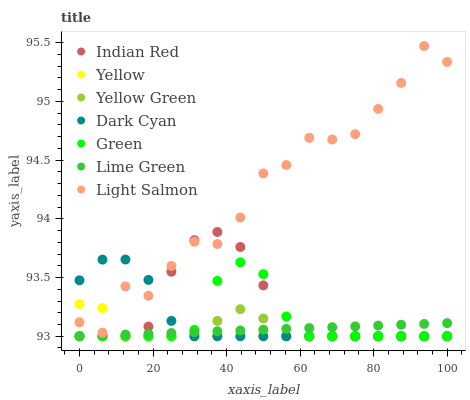Does Yellow have the minimum area under the curve?
Answer yes or no. Yes. Does Light Salmon have the maximum area under the curve?
Answer yes or no. Yes. Does Yellow Green have the minimum area under the curve?
Answer yes or no. No. Does Yellow Green have the maximum area under the curve?
Answer yes or no. No. Is Lime Green the smoothest?
Answer yes or no. Yes. Is Light Salmon the roughest?
Answer yes or no. Yes. Is Yellow Green the smoothest?
Answer yes or no. No. Is Yellow Green the roughest?
Answer yes or no. No. Does Yellow Green have the lowest value?
Answer yes or no. Yes. Does Light Salmon have the highest value?
Answer yes or no. Yes. Does Yellow Green have the highest value?
Answer yes or no. No. Is Lime Green less than Light Salmon?
Answer yes or no. Yes. Is Light Salmon greater than Green?
Answer yes or no. Yes. Does Indian Red intersect Yellow?
Answer yes or no. Yes. Is Indian Red less than Yellow?
Answer yes or no. No. Is Indian Red greater than Yellow?
Answer yes or no. No. Does Lime Green intersect Light Salmon?
Answer yes or no. No. 